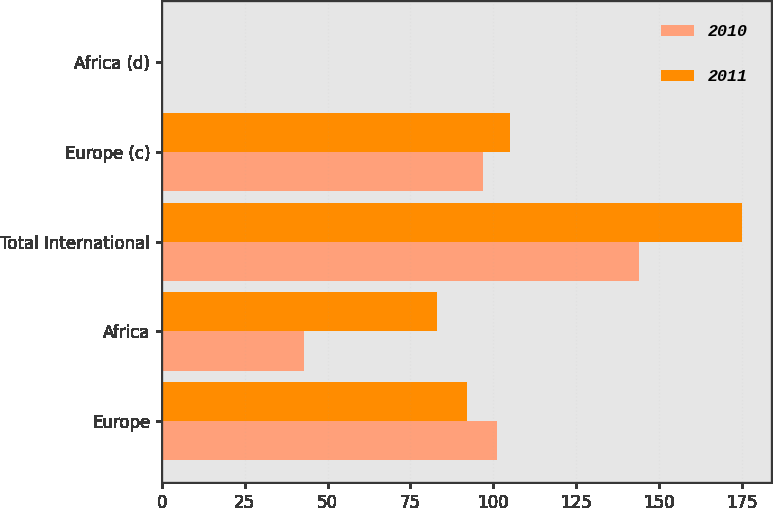Convert chart. <chart><loc_0><loc_0><loc_500><loc_500><stacked_bar_chart><ecel><fcel>Europe<fcel>Africa<fcel>Total International<fcel>Europe (c)<fcel>Africa (d)<nl><fcel>2010<fcel>101<fcel>43<fcel>144<fcel>97<fcel>0.24<nl><fcel>2011<fcel>92<fcel>83<fcel>175<fcel>105<fcel>0.25<nl></chart> 